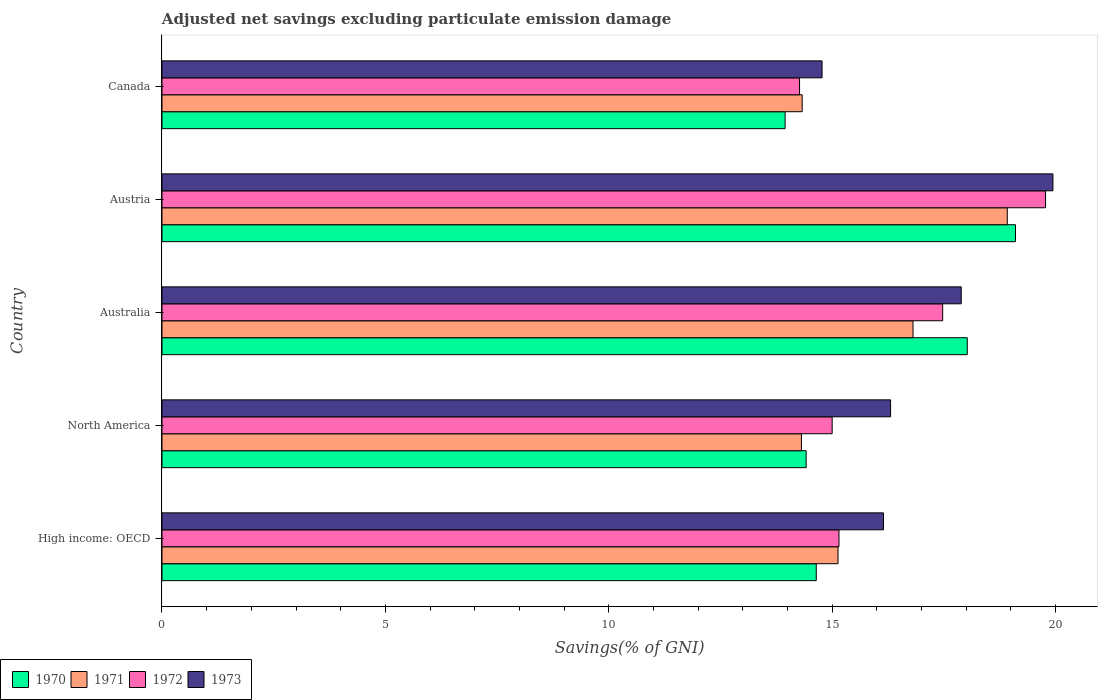How many groups of bars are there?
Make the answer very short. 5. Are the number of bars on each tick of the Y-axis equal?
Make the answer very short. Yes. How many bars are there on the 4th tick from the top?
Provide a succinct answer. 4. What is the label of the 3rd group of bars from the top?
Your answer should be very brief. Australia. What is the adjusted net savings in 1972 in Australia?
Your answer should be very brief. 17.48. Across all countries, what is the maximum adjusted net savings in 1970?
Your answer should be compact. 19.11. Across all countries, what is the minimum adjusted net savings in 1973?
Provide a short and direct response. 14.78. In which country was the adjusted net savings in 1972 maximum?
Offer a very short reply. Austria. What is the total adjusted net savings in 1970 in the graph?
Provide a succinct answer. 80.15. What is the difference between the adjusted net savings in 1971 in Australia and that in Austria?
Provide a succinct answer. -2.11. What is the difference between the adjusted net savings in 1971 in Austria and the adjusted net savings in 1973 in High income: OECD?
Your answer should be very brief. 2.77. What is the average adjusted net savings in 1973 per country?
Offer a very short reply. 17.01. What is the difference between the adjusted net savings in 1973 and adjusted net savings in 1970 in North America?
Your answer should be compact. 1.89. In how many countries, is the adjusted net savings in 1973 greater than 14 %?
Make the answer very short. 5. What is the ratio of the adjusted net savings in 1973 in Austria to that in North America?
Keep it short and to the point. 1.22. Is the adjusted net savings in 1972 in High income: OECD less than that in North America?
Your response must be concise. No. What is the difference between the highest and the second highest adjusted net savings in 1971?
Ensure brevity in your answer.  2.11. What is the difference between the highest and the lowest adjusted net savings in 1971?
Keep it short and to the point. 4.61. Is the sum of the adjusted net savings in 1970 in Austria and High income: OECD greater than the maximum adjusted net savings in 1973 across all countries?
Your answer should be compact. Yes. How many bars are there?
Provide a succinct answer. 20. Are all the bars in the graph horizontal?
Offer a terse response. Yes. How many countries are there in the graph?
Make the answer very short. 5. How many legend labels are there?
Provide a succinct answer. 4. How are the legend labels stacked?
Your answer should be compact. Horizontal. What is the title of the graph?
Offer a very short reply. Adjusted net savings excluding particulate emission damage. Does "1974" appear as one of the legend labels in the graph?
Keep it short and to the point. No. What is the label or title of the X-axis?
Your response must be concise. Savings(% of GNI). What is the label or title of the Y-axis?
Your answer should be compact. Country. What is the Savings(% of GNI) in 1970 in High income: OECD?
Give a very brief answer. 14.65. What is the Savings(% of GNI) in 1971 in High income: OECD?
Make the answer very short. 15.13. What is the Savings(% of GNI) of 1972 in High income: OECD?
Provide a succinct answer. 15.15. What is the Savings(% of GNI) in 1973 in High income: OECD?
Keep it short and to the point. 16.15. What is the Savings(% of GNI) of 1970 in North America?
Keep it short and to the point. 14.42. What is the Savings(% of GNI) in 1971 in North America?
Offer a terse response. 14.31. What is the Savings(% of GNI) of 1972 in North America?
Provide a short and direct response. 15. What is the Savings(% of GNI) of 1973 in North America?
Make the answer very short. 16.31. What is the Savings(% of GNI) in 1970 in Australia?
Keep it short and to the point. 18.03. What is the Savings(% of GNI) in 1971 in Australia?
Give a very brief answer. 16.81. What is the Savings(% of GNI) of 1972 in Australia?
Your answer should be compact. 17.48. What is the Savings(% of GNI) in 1973 in Australia?
Your answer should be compact. 17.89. What is the Savings(% of GNI) of 1970 in Austria?
Make the answer very short. 19.11. What is the Savings(% of GNI) of 1971 in Austria?
Provide a succinct answer. 18.92. What is the Savings(% of GNI) in 1972 in Austria?
Provide a short and direct response. 19.78. What is the Savings(% of GNI) of 1973 in Austria?
Your response must be concise. 19.94. What is the Savings(% of GNI) in 1970 in Canada?
Offer a very short reply. 13.95. What is the Savings(% of GNI) of 1971 in Canada?
Give a very brief answer. 14.33. What is the Savings(% of GNI) in 1972 in Canada?
Ensure brevity in your answer.  14.27. What is the Savings(% of GNI) of 1973 in Canada?
Your answer should be very brief. 14.78. Across all countries, what is the maximum Savings(% of GNI) of 1970?
Your answer should be compact. 19.11. Across all countries, what is the maximum Savings(% of GNI) in 1971?
Offer a terse response. 18.92. Across all countries, what is the maximum Savings(% of GNI) of 1972?
Your response must be concise. 19.78. Across all countries, what is the maximum Savings(% of GNI) of 1973?
Provide a short and direct response. 19.94. Across all countries, what is the minimum Savings(% of GNI) of 1970?
Offer a very short reply. 13.95. Across all countries, what is the minimum Savings(% of GNI) in 1971?
Keep it short and to the point. 14.31. Across all countries, what is the minimum Savings(% of GNI) of 1972?
Make the answer very short. 14.27. Across all countries, what is the minimum Savings(% of GNI) in 1973?
Ensure brevity in your answer.  14.78. What is the total Savings(% of GNI) in 1970 in the graph?
Your answer should be compact. 80.15. What is the total Savings(% of GNI) of 1971 in the graph?
Offer a terse response. 79.51. What is the total Savings(% of GNI) in 1972 in the graph?
Offer a very short reply. 81.68. What is the total Savings(% of GNI) in 1973 in the graph?
Your answer should be very brief. 85.07. What is the difference between the Savings(% of GNI) of 1970 in High income: OECD and that in North America?
Your response must be concise. 0.23. What is the difference between the Savings(% of GNI) in 1971 in High income: OECD and that in North America?
Your response must be concise. 0.82. What is the difference between the Savings(% of GNI) in 1972 in High income: OECD and that in North America?
Keep it short and to the point. 0.15. What is the difference between the Savings(% of GNI) of 1973 in High income: OECD and that in North America?
Your answer should be very brief. -0.16. What is the difference between the Savings(% of GNI) of 1970 in High income: OECD and that in Australia?
Provide a short and direct response. -3.38. What is the difference between the Savings(% of GNI) in 1971 in High income: OECD and that in Australia?
Make the answer very short. -1.68. What is the difference between the Savings(% of GNI) of 1972 in High income: OECD and that in Australia?
Offer a very short reply. -2.32. What is the difference between the Savings(% of GNI) in 1973 in High income: OECD and that in Australia?
Your answer should be compact. -1.74. What is the difference between the Savings(% of GNI) in 1970 in High income: OECD and that in Austria?
Offer a very short reply. -4.46. What is the difference between the Savings(% of GNI) in 1971 in High income: OECD and that in Austria?
Give a very brief answer. -3.79. What is the difference between the Savings(% of GNI) in 1972 in High income: OECD and that in Austria?
Keep it short and to the point. -4.62. What is the difference between the Savings(% of GNI) in 1973 in High income: OECD and that in Austria?
Provide a short and direct response. -3.79. What is the difference between the Savings(% of GNI) of 1970 in High income: OECD and that in Canada?
Provide a succinct answer. 0.7. What is the difference between the Savings(% of GNI) of 1971 in High income: OECD and that in Canada?
Your answer should be compact. 0.8. What is the difference between the Savings(% of GNI) in 1972 in High income: OECD and that in Canada?
Ensure brevity in your answer.  0.88. What is the difference between the Savings(% of GNI) in 1973 in High income: OECD and that in Canada?
Offer a terse response. 1.38. What is the difference between the Savings(% of GNI) in 1970 in North America and that in Australia?
Offer a very short reply. -3.61. What is the difference between the Savings(% of GNI) of 1971 in North America and that in Australia?
Your answer should be compact. -2.5. What is the difference between the Savings(% of GNI) in 1972 in North America and that in Australia?
Give a very brief answer. -2.47. What is the difference between the Savings(% of GNI) in 1973 in North America and that in Australia?
Provide a succinct answer. -1.58. What is the difference between the Savings(% of GNI) in 1970 in North America and that in Austria?
Make the answer very short. -4.69. What is the difference between the Savings(% of GNI) of 1971 in North America and that in Austria?
Make the answer very short. -4.61. What is the difference between the Savings(% of GNI) of 1972 in North America and that in Austria?
Your response must be concise. -4.78. What is the difference between the Savings(% of GNI) of 1973 in North America and that in Austria?
Ensure brevity in your answer.  -3.63. What is the difference between the Savings(% of GNI) in 1970 in North America and that in Canada?
Your response must be concise. 0.47. What is the difference between the Savings(% of GNI) in 1971 in North America and that in Canada?
Provide a succinct answer. -0.02. What is the difference between the Savings(% of GNI) in 1972 in North America and that in Canada?
Your answer should be compact. 0.73. What is the difference between the Savings(% of GNI) in 1973 in North America and that in Canada?
Provide a succinct answer. 1.53. What is the difference between the Savings(% of GNI) in 1970 in Australia and that in Austria?
Offer a terse response. -1.08. What is the difference between the Savings(% of GNI) in 1971 in Australia and that in Austria?
Your response must be concise. -2.11. What is the difference between the Savings(% of GNI) of 1972 in Australia and that in Austria?
Offer a very short reply. -2.3. What is the difference between the Savings(% of GNI) of 1973 in Australia and that in Austria?
Your answer should be compact. -2.05. What is the difference between the Savings(% of GNI) in 1970 in Australia and that in Canada?
Make the answer very short. 4.08. What is the difference between the Savings(% of GNI) in 1971 in Australia and that in Canada?
Offer a terse response. 2.48. What is the difference between the Savings(% of GNI) of 1972 in Australia and that in Canada?
Your answer should be very brief. 3.2. What is the difference between the Savings(% of GNI) in 1973 in Australia and that in Canada?
Provide a short and direct response. 3.12. What is the difference between the Savings(% of GNI) in 1970 in Austria and that in Canada?
Provide a succinct answer. 5.16. What is the difference between the Savings(% of GNI) of 1971 in Austria and that in Canada?
Offer a terse response. 4.59. What is the difference between the Savings(% of GNI) in 1972 in Austria and that in Canada?
Offer a terse response. 5.51. What is the difference between the Savings(% of GNI) in 1973 in Austria and that in Canada?
Offer a terse response. 5.17. What is the difference between the Savings(% of GNI) in 1970 in High income: OECD and the Savings(% of GNI) in 1971 in North America?
Provide a short and direct response. 0.33. What is the difference between the Savings(% of GNI) in 1970 in High income: OECD and the Savings(% of GNI) in 1972 in North America?
Your answer should be very brief. -0.36. What is the difference between the Savings(% of GNI) of 1970 in High income: OECD and the Savings(% of GNI) of 1973 in North America?
Your answer should be compact. -1.66. What is the difference between the Savings(% of GNI) of 1971 in High income: OECD and the Savings(% of GNI) of 1972 in North America?
Your answer should be very brief. 0.13. What is the difference between the Savings(% of GNI) of 1971 in High income: OECD and the Savings(% of GNI) of 1973 in North America?
Make the answer very short. -1.18. What is the difference between the Savings(% of GNI) in 1972 in High income: OECD and the Savings(% of GNI) in 1973 in North America?
Your answer should be compact. -1.15. What is the difference between the Savings(% of GNI) in 1970 in High income: OECD and the Savings(% of GNI) in 1971 in Australia?
Provide a short and direct response. -2.17. What is the difference between the Savings(% of GNI) in 1970 in High income: OECD and the Savings(% of GNI) in 1972 in Australia?
Offer a very short reply. -2.83. What is the difference between the Savings(% of GNI) of 1970 in High income: OECD and the Savings(% of GNI) of 1973 in Australia?
Your answer should be very brief. -3.25. What is the difference between the Savings(% of GNI) of 1971 in High income: OECD and the Savings(% of GNI) of 1972 in Australia?
Ensure brevity in your answer.  -2.34. What is the difference between the Savings(% of GNI) of 1971 in High income: OECD and the Savings(% of GNI) of 1973 in Australia?
Your answer should be compact. -2.76. What is the difference between the Savings(% of GNI) in 1972 in High income: OECD and the Savings(% of GNI) in 1973 in Australia?
Your answer should be very brief. -2.74. What is the difference between the Savings(% of GNI) of 1970 in High income: OECD and the Savings(% of GNI) of 1971 in Austria?
Keep it short and to the point. -4.28. What is the difference between the Savings(% of GNI) of 1970 in High income: OECD and the Savings(% of GNI) of 1972 in Austria?
Offer a very short reply. -5.13. What is the difference between the Savings(% of GNI) of 1970 in High income: OECD and the Savings(% of GNI) of 1973 in Austria?
Offer a very short reply. -5.3. What is the difference between the Savings(% of GNI) in 1971 in High income: OECD and the Savings(% of GNI) in 1972 in Austria?
Provide a short and direct response. -4.64. What is the difference between the Savings(% of GNI) of 1971 in High income: OECD and the Savings(% of GNI) of 1973 in Austria?
Provide a succinct answer. -4.81. What is the difference between the Savings(% of GNI) of 1972 in High income: OECD and the Savings(% of GNI) of 1973 in Austria?
Ensure brevity in your answer.  -4.79. What is the difference between the Savings(% of GNI) in 1970 in High income: OECD and the Savings(% of GNI) in 1971 in Canada?
Your answer should be compact. 0.32. What is the difference between the Savings(% of GNI) in 1970 in High income: OECD and the Savings(% of GNI) in 1972 in Canada?
Make the answer very short. 0.37. What is the difference between the Savings(% of GNI) of 1970 in High income: OECD and the Savings(% of GNI) of 1973 in Canada?
Your answer should be compact. -0.13. What is the difference between the Savings(% of GNI) in 1971 in High income: OECD and the Savings(% of GNI) in 1972 in Canada?
Your response must be concise. 0.86. What is the difference between the Savings(% of GNI) in 1971 in High income: OECD and the Savings(% of GNI) in 1973 in Canada?
Your answer should be compact. 0.36. What is the difference between the Savings(% of GNI) of 1972 in High income: OECD and the Savings(% of GNI) of 1973 in Canada?
Your answer should be compact. 0.38. What is the difference between the Savings(% of GNI) in 1970 in North America and the Savings(% of GNI) in 1971 in Australia?
Offer a very short reply. -2.39. What is the difference between the Savings(% of GNI) in 1970 in North America and the Savings(% of GNI) in 1972 in Australia?
Provide a short and direct response. -3.06. What is the difference between the Savings(% of GNI) of 1970 in North America and the Savings(% of GNI) of 1973 in Australia?
Your response must be concise. -3.47. What is the difference between the Savings(% of GNI) of 1971 in North America and the Savings(% of GNI) of 1972 in Australia?
Keep it short and to the point. -3.16. What is the difference between the Savings(% of GNI) in 1971 in North America and the Savings(% of GNI) in 1973 in Australia?
Your answer should be compact. -3.58. What is the difference between the Savings(% of GNI) of 1972 in North America and the Savings(% of GNI) of 1973 in Australia?
Keep it short and to the point. -2.89. What is the difference between the Savings(% of GNI) in 1970 in North America and the Savings(% of GNI) in 1971 in Austria?
Provide a succinct answer. -4.5. What is the difference between the Savings(% of GNI) of 1970 in North America and the Savings(% of GNI) of 1972 in Austria?
Provide a short and direct response. -5.36. What is the difference between the Savings(% of GNI) in 1970 in North America and the Savings(% of GNI) in 1973 in Austria?
Your response must be concise. -5.52. What is the difference between the Savings(% of GNI) in 1971 in North America and the Savings(% of GNI) in 1972 in Austria?
Ensure brevity in your answer.  -5.46. What is the difference between the Savings(% of GNI) in 1971 in North America and the Savings(% of GNI) in 1973 in Austria?
Offer a terse response. -5.63. What is the difference between the Savings(% of GNI) of 1972 in North America and the Savings(% of GNI) of 1973 in Austria?
Your answer should be compact. -4.94. What is the difference between the Savings(% of GNI) of 1970 in North America and the Savings(% of GNI) of 1971 in Canada?
Offer a terse response. 0.09. What is the difference between the Savings(% of GNI) of 1970 in North America and the Savings(% of GNI) of 1972 in Canada?
Provide a succinct answer. 0.15. What is the difference between the Savings(% of GNI) of 1970 in North America and the Savings(% of GNI) of 1973 in Canada?
Offer a very short reply. -0.36. What is the difference between the Savings(% of GNI) of 1971 in North America and the Savings(% of GNI) of 1972 in Canada?
Give a very brief answer. 0.04. What is the difference between the Savings(% of GNI) in 1971 in North America and the Savings(% of GNI) in 1973 in Canada?
Your answer should be compact. -0.46. What is the difference between the Savings(% of GNI) in 1972 in North America and the Savings(% of GNI) in 1973 in Canada?
Give a very brief answer. 0.23. What is the difference between the Savings(% of GNI) of 1970 in Australia and the Savings(% of GNI) of 1971 in Austria?
Give a very brief answer. -0.9. What is the difference between the Savings(% of GNI) of 1970 in Australia and the Savings(% of GNI) of 1972 in Austria?
Provide a succinct answer. -1.75. What is the difference between the Savings(% of GNI) of 1970 in Australia and the Savings(% of GNI) of 1973 in Austria?
Make the answer very short. -1.92. What is the difference between the Savings(% of GNI) of 1971 in Australia and the Savings(% of GNI) of 1972 in Austria?
Your answer should be very brief. -2.97. What is the difference between the Savings(% of GNI) of 1971 in Australia and the Savings(% of GNI) of 1973 in Austria?
Provide a short and direct response. -3.13. What is the difference between the Savings(% of GNI) in 1972 in Australia and the Savings(% of GNI) in 1973 in Austria?
Offer a terse response. -2.47. What is the difference between the Savings(% of GNI) in 1970 in Australia and the Savings(% of GNI) in 1971 in Canada?
Make the answer very short. 3.7. What is the difference between the Savings(% of GNI) in 1970 in Australia and the Savings(% of GNI) in 1972 in Canada?
Ensure brevity in your answer.  3.75. What is the difference between the Savings(% of GNI) of 1970 in Australia and the Savings(% of GNI) of 1973 in Canada?
Ensure brevity in your answer.  3.25. What is the difference between the Savings(% of GNI) of 1971 in Australia and the Savings(% of GNI) of 1972 in Canada?
Provide a succinct answer. 2.54. What is the difference between the Savings(% of GNI) in 1971 in Australia and the Savings(% of GNI) in 1973 in Canada?
Make the answer very short. 2.04. What is the difference between the Savings(% of GNI) of 1970 in Austria and the Savings(% of GNI) of 1971 in Canada?
Provide a succinct answer. 4.77. What is the difference between the Savings(% of GNI) in 1970 in Austria and the Savings(% of GNI) in 1972 in Canada?
Offer a terse response. 4.83. What is the difference between the Savings(% of GNI) of 1970 in Austria and the Savings(% of GNI) of 1973 in Canada?
Give a very brief answer. 4.33. What is the difference between the Savings(% of GNI) of 1971 in Austria and the Savings(% of GNI) of 1972 in Canada?
Offer a very short reply. 4.65. What is the difference between the Savings(% of GNI) in 1971 in Austria and the Savings(% of GNI) in 1973 in Canada?
Offer a terse response. 4.15. What is the difference between the Savings(% of GNI) of 1972 in Austria and the Savings(% of GNI) of 1973 in Canada?
Provide a succinct answer. 5. What is the average Savings(% of GNI) of 1970 per country?
Your answer should be very brief. 16.03. What is the average Savings(% of GNI) of 1971 per country?
Your answer should be compact. 15.9. What is the average Savings(% of GNI) in 1972 per country?
Offer a terse response. 16.34. What is the average Savings(% of GNI) of 1973 per country?
Provide a short and direct response. 17.01. What is the difference between the Savings(% of GNI) of 1970 and Savings(% of GNI) of 1971 in High income: OECD?
Your answer should be compact. -0.49. What is the difference between the Savings(% of GNI) in 1970 and Savings(% of GNI) in 1972 in High income: OECD?
Your answer should be compact. -0.51. What is the difference between the Savings(% of GNI) of 1970 and Savings(% of GNI) of 1973 in High income: OECD?
Make the answer very short. -1.51. What is the difference between the Savings(% of GNI) of 1971 and Savings(% of GNI) of 1972 in High income: OECD?
Ensure brevity in your answer.  -0.02. What is the difference between the Savings(% of GNI) in 1971 and Savings(% of GNI) in 1973 in High income: OECD?
Offer a terse response. -1.02. What is the difference between the Savings(% of GNI) of 1972 and Savings(% of GNI) of 1973 in High income: OECD?
Offer a terse response. -1. What is the difference between the Savings(% of GNI) of 1970 and Savings(% of GNI) of 1971 in North America?
Offer a terse response. 0.11. What is the difference between the Savings(% of GNI) of 1970 and Savings(% of GNI) of 1972 in North America?
Provide a succinct answer. -0.58. What is the difference between the Savings(% of GNI) in 1970 and Savings(% of GNI) in 1973 in North America?
Give a very brief answer. -1.89. What is the difference between the Savings(% of GNI) in 1971 and Savings(% of GNI) in 1972 in North America?
Provide a short and direct response. -0.69. What is the difference between the Savings(% of GNI) of 1971 and Savings(% of GNI) of 1973 in North America?
Provide a short and direct response. -2. What is the difference between the Savings(% of GNI) in 1972 and Savings(% of GNI) in 1973 in North America?
Your answer should be compact. -1.31. What is the difference between the Savings(% of GNI) in 1970 and Savings(% of GNI) in 1971 in Australia?
Make the answer very short. 1.21. What is the difference between the Savings(% of GNI) in 1970 and Savings(% of GNI) in 1972 in Australia?
Your answer should be compact. 0.55. What is the difference between the Savings(% of GNI) in 1970 and Savings(% of GNI) in 1973 in Australia?
Your answer should be very brief. 0.13. What is the difference between the Savings(% of GNI) of 1971 and Savings(% of GNI) of 1972 in Australia?
Offer a terse response. -0.66. What is the difference between the Savings(% of GNI) in 1971 and Savings(% of GNI) in 1973 in Australia?
Give a very brief answer. -1.08. What is the difference between the Savings(% of GNI) in 1972 and Savings(% of GNI) in 1973 in Australia?
Offer a terse response. -0.42. What is the difference between the Savings(% of GNI) of 1970 and Savings(% of GNI) of 1971 in Austria?
Your answer should be compact. 0.18. What is the difference between the Savings(% of GNI) of 1970 and Savings(% of GNI) of 1972 in Austria?
Provide a short and direct response. -0.67. What is the difference between the Savings(% of GNI) of 1970 and Savings(% of GNI) of 1973 in Austria?
Provide a short and direct response. -0.84. What is the difference between the Savings(% of GNI) of 1971 and Savings(% of GNI) of 1972 in Austria?
Your answer should be compact. -0.86. What is the difference between the Savings(% of GNI) in 1971 and Savings(% of GNI) in 1973 in Austria?
Keep it short and to the point. -1.02. What is the difference between the Savings(% of GNI) of 1972 and Savings(% of GNI) of 1973 in Austria?
Offer a terse response. -0.17. What is the difference between the Savings(% of GNI) of 1970 and Savings(% of GNI) of 1971 in Canada?
Make the answer very short. -0.38. What is the difference between the Savings(% of GNI) of 1970 and Savings(% of GNI) of 1972 in Canada?
Your answer should be very brief. -0.32. What is the difference between the Savings(% of GNI) in 1970 and Savings(% of GNI) in 1973 in Canada?
Make the answer very short. -0.83. What is the difference between the Savings(% of GNI) of 1971 and Savings(% of GNI) of 1972 in Canada?
Make the answer very short. 0.06. What is the difference between the Savings(% of GNI) in 1971 and Savings(% of GNI) in 1973 in Canada?
Make the answer very short. -0.45. What is the difference between the Savings(% of GNI) of 1972 and Savings(% of GNI) of 1973 in Canada?
Your response must be concise. -0.5. What is the ratio of the Savings(% of GNI) in 1970 in High income: OECD to that in North America?
Ensure brevity in your answer.  1.02. What is the ratio of the Savings(% of GNI) of 1971 in High income: OECD to that in North America?
Your answer should be compact. 1.06. What is the ratio of the Savings(% of GNI) in 1972 in High income: OECD to that in North America?
Make the answer very short. 1.01. What is the ratio of the Savings(% of GNI) in 1973 in High income: OECD to that in North America?
Offer a terse response. 0.99. What is the ratio of the Savings(% of GNI) of 1970 in High income: OECD to that in Australia?
Make the answer very short. 0.81. What is the ratio of the Savings(% of GNI) in 1971 in High income: OECD to that in Australia?
Ensure brevity in your answer.  0.9. What is the ratio of the Savings(% of GNI) in 1972 in High income: OECD to that in Australia?
Your answer should be very brief. 0.87. What is the ratio of the Savings(% of GNI) of 1973 in High income: OECD to that in Australia?
Provide a succinct answer. 0.9. What is the ratio of the Savings(% of GNI) in 1970 in High income: OECD to that in Austria?
Offer a very short reply. 0.77. What is the ratio of the Savings(% of GNI) of 1971 in High income: OECD to that in Austria?
Your answer should be compact. 0.8. What is the ratio of the Savings(% of GNI) of 1972 in High income: OECD to that in Austria?
Your response must be concise. 0.77. What is the ratio of the Savings(% of GNI) of 1973 in High income: OECD to that in Austria?
Your response must be concise. 0.81. What is the ratio of the Savings(% of GNI) in 1971 in High income: OECD to that in Canada?
Keep it short and to the point. 1.06. What is the ratio of the Savings(% of GNI) of 1972 in High income: OECD to that in Canada?
Your answer should be very brief. 1.06. What is the ratio of the Savings(% of GNI) in 1973 in High income: OECD to that in Canada?
Provide a succinct answer. 1.09. What is the ratio of the Savings(% of GNI) of 1970 in North America to that in Australia?
Your response must be concise. 0.8. What is the ratio of the Savings(% of GNI) of 1971 in North America to that in Australia?
Ensure brevity in your answer.  0.85. What is the ratio of the Savings(% of GNI) in 1972 in North America to that in Australia?
Provide a succinct answer. 0.86. What is the ratio of the Savings(% of GNI) in 1973 in North America to that in Australia?
Give a very brief answer. 0.91. What is the ratio of the Savings(% of GNI) in 1970 in North America to that in Austria?
Your answer should be very brief. 0.75. What is the ratio of the Savings(% of GNI) in 1971 in North America to that in Austria?
Your answer should be compact. 0.76. What is the ratio of the Savings(% of GNI) in 1972 in North America to that in Austria?
Ensure brevity in your answer.  0.76. What is the ratio of the Savings(% of GNI) of 1973 in North America to that in Austria?
Make the answer very short. 0.82. What is the ratio of the Savings(% of GNI) in 1970 in North America to that in Canada?
Offer a terse response. 1.03. What is the ratio of the Savings(% of GNI) of 1971 in North America to that in Canada?
Make the answer very short. 1. What is the ratio of the Savings(% of GNI) of 1972 in North America to that in Canada?
Offer a very short reply. 1.05. What is the ratio of the Savings(% of GNI) of 1973 in North America to that in Canada?
Offer a very short reply. 1.1. What is the ratio of the Savings(% of GNI) of 1970 in Australia to that in Austria?
Offer a very short reply. 0.94. What is the ratio of the Savings(% of GNI) of 1971 in Australia to that in Austria?
Provide a short and direct response. 0.89. What is the ratio of the Savings(% of GNI) of 1972 in Australia to that in Austria?
Your answer should be compact. 0.88. What is the ratio of the Savings(% of GNI) of 1973 in Australia to that in Austria?
Provide a succinct answer. 0.9. What is the ratio of the Savings(% of GNI) in 1970 in Australia to that in Canada?
Make the answer very short. 1.29. What is the ratio of the Savings(% of GNI) of 1971 in Australia to that in Canada?
Offer a terse response. 1.17. What is the ratio of the Savings(% of GNI) in 1972 in Australia to that in Canada?
Offer a terse response. 1.22. What is the ratio of the Savings(% of GNI) of 1973 in Australia to that in Canada?
Your answer should be compact. 1.21. What is the ratio of the Savings(% of GNI) of 1970 in Austria to that in Canada?
Your answer should be compact. 1.37. What is the ratio of the Savings(% of GNI) in 1971 in Austria to that in Canada?
Provide a succinct answer. 1.32. What is the ratio of the Savings(% of GNI) of 1972 in Austria to that in Canada?
Make the answer very short. 1.39. What is the ratio of the Savings(% of GNI) of 1973 in Austria to that in Canada?
Your answer should be very brief. 1.35. What is the difference between the highest and the second highest Savings(% of GNI) in 1970?
Ensure brevity in your answer.  1.08. What is the difference between the highest and the second highest Savings(% of GNI) of 1971?
Your response must be concise. 2.11. What is the difference between the highest and the second highest Savings(% of GNI) of 1972?
Ensure brevity in your answer.  2.3. What is the difference between the highest and the second highest Savings(% of GNI) in 1973?
Your answer should be compact. 2.05. What is the difference between the highest and the lowest Savings(% of GNI) in 1970?
Offer a terse response. 5.16. What is the difference between the highest and the lowest Savings(% of GNI) in 1971?
Your response must be concise. 4.61. What is the difference between the highest and the lowest Savings(% of GNI) of 1972?
Your response must be concise. 5.51. What is the difference between the highest and the lowest Savings(% of GNI) in 1973?
Ensure brevity in your answer.  5.17. 